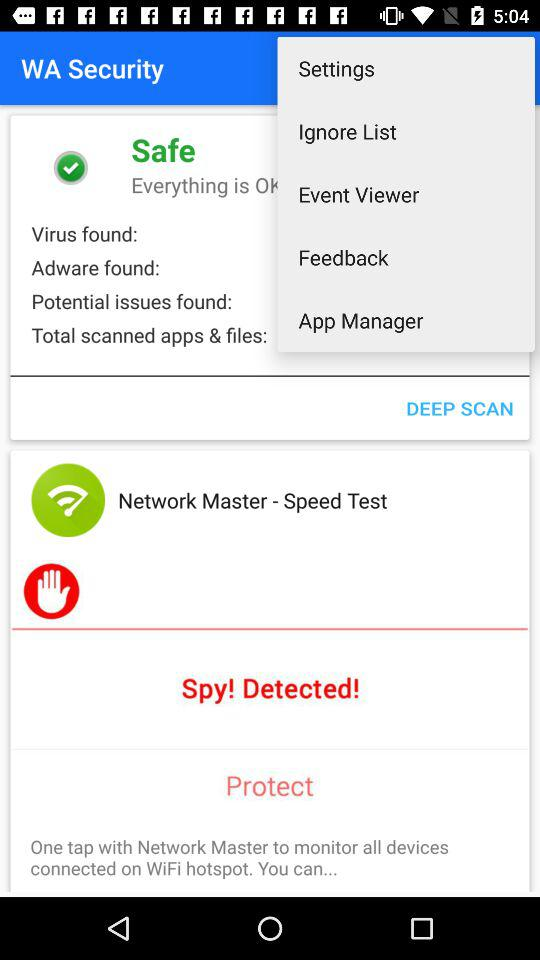What is the number of "Virus found"? The number is 0. 